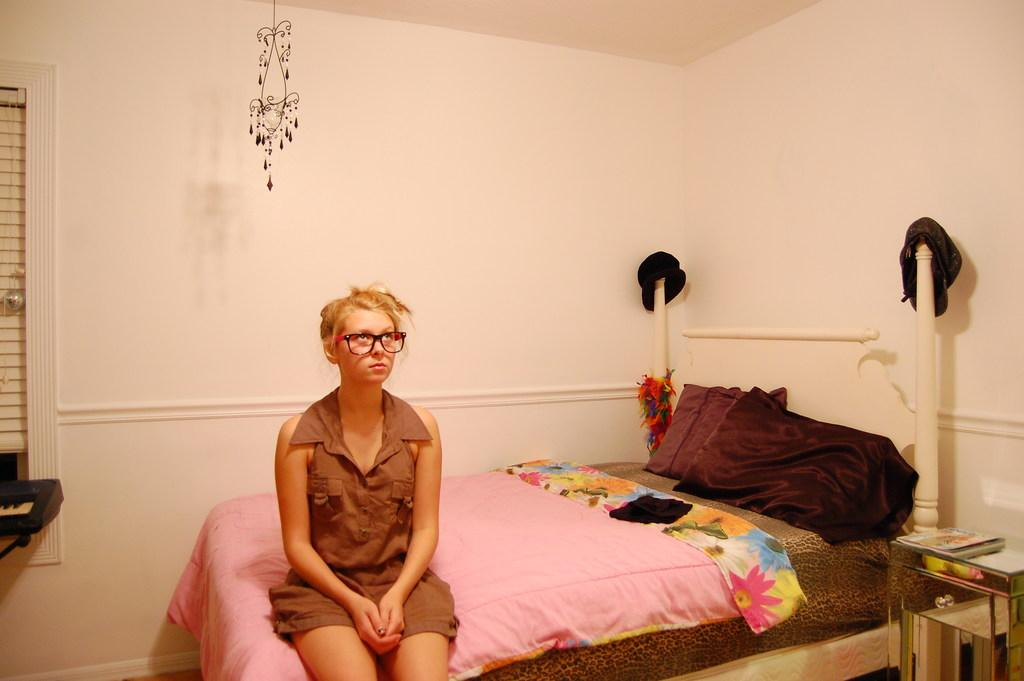What is the lady in the image doing? The lady is sitting on the bed in the image. What can be seen hanging from the ceiling in the image? There is a chandelier hanging from the ceiling in the image. Where is the window located in the image? The window is in the left corner of the image. What type of cake is being served during the thunderstorm in the image? There is no cake or thunderstorm present in the image; it features a lady sitting on a bed with a chandelier and a window. 